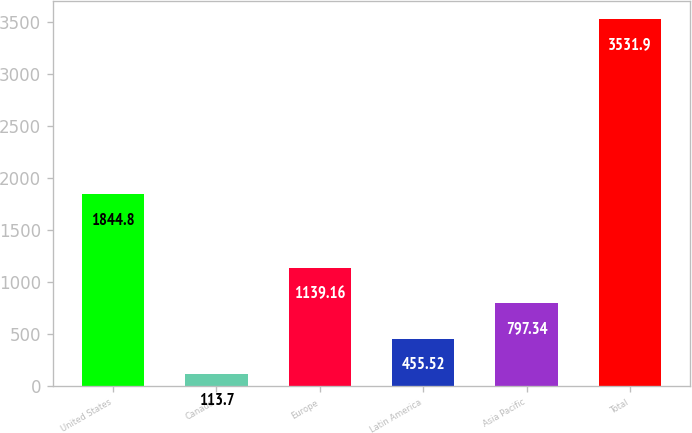<chart> <loc_0><loc_0><loc_500><loc_500><bar_chart><fcel>United States<fcel>Canada<fcel>Europe<fcel>Latin America<fcel>Asia Pacific<fcel>Total<nl><fcel>1844.8<fcel>113.7<fcel>1139.16<fcel>455.52<fcel>797.34<fcel>3531.9<nl></chart> 